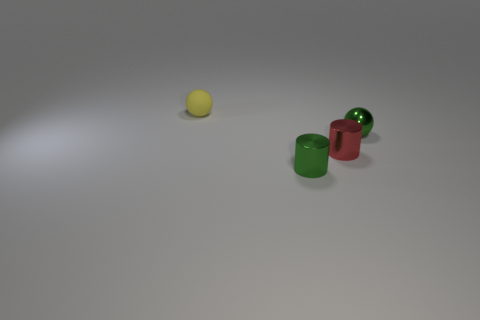Is there anything else that has the same material as the tiny yellow ball?
Your answer should be compact. No. There is a green metal thing to the right of the green metallic thing left of the small green shiny sphere; what shape is it?
Keep it short and to the point. Sphere. Is there a tiny sphere made of the same material as the tiny red cylinder?
Offer a terse response. Yes. There is another tiny object that is the same shape as the yellow thing; what is its color?
Ensure brevity in your answer.  Green. Are there fewer small red objects that are on the right side of the small red shiny thing than small matte objects that are on the right side of the small green sphere?
Your answer should be compact. No. How many other objects are there of the same shape as the small red object?
Give a very brief answer. 1. Are there fewer tiny yellow balls right of the matte object than small brown metallic spheres?
Your response must be concise. No. There is a small ball on the left side of the tiny green metallic cylinder; what is it made of?
Give a very brief answer. Rubber. What number of other objects are there of the same size as the red cylinder?
Make the answer very short. 3. Are there fewer cylinders than small things?
Your answer should be very brief. Yes. 